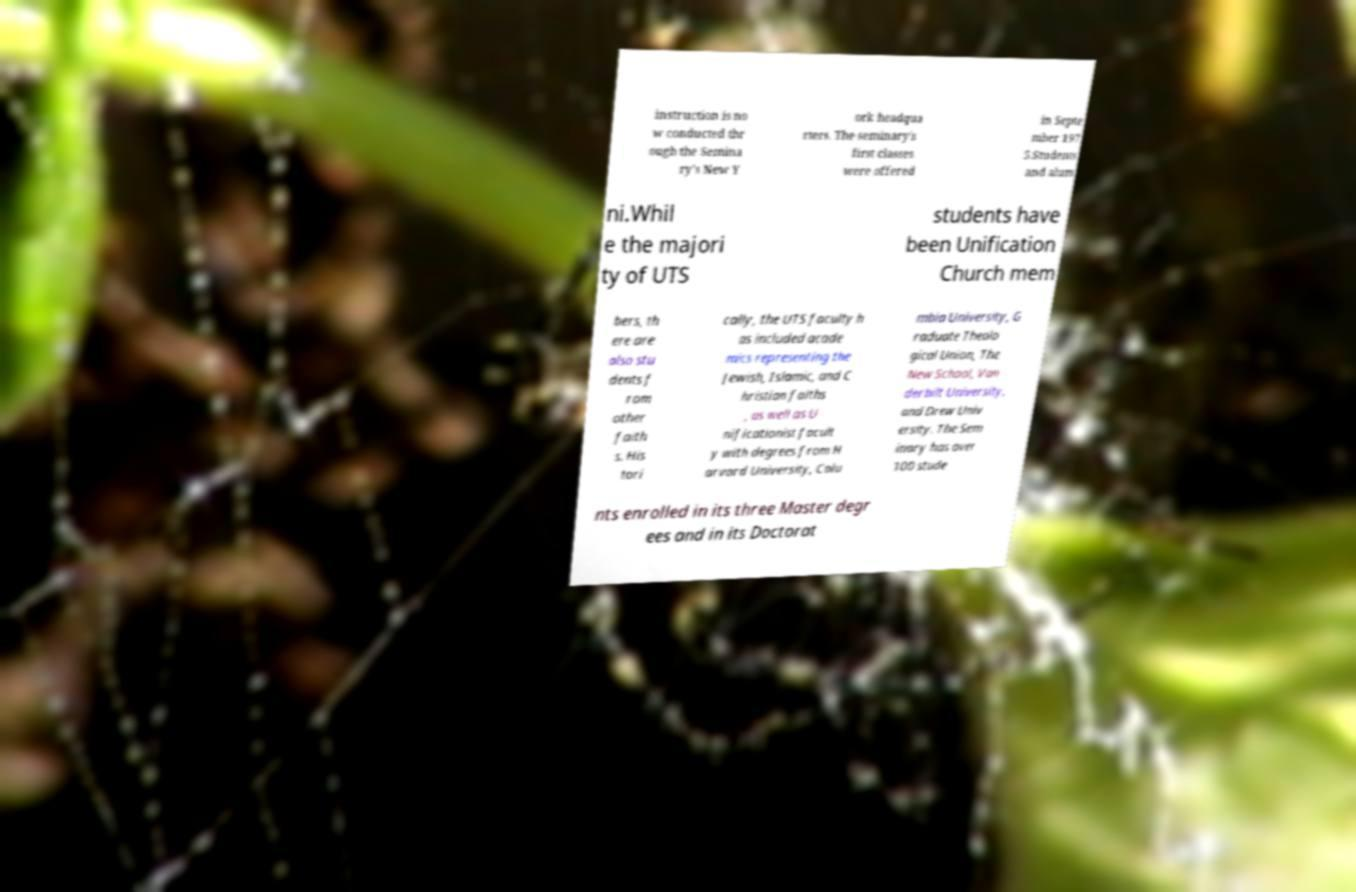Please identify and transcribe the text found in this image. instruction is no w conducted thr ough the Semina ry’s New Y ork headqua rters. The seminary's first classes were offered in Septe mber 197 5.Students and alum ni.Whil e the majori ty of UTS students have been Unification Church mem bers, th ere are also stu dents f rom other faith s. His tori cally, the UTS faculty h as included acade mics representing the Jewish, Islamic, and C hristian faiths , as well as U nificationist facult y with degrees from H arvard University, Colu mbia University, G raduate Theolo gical Union, The New School, Van derbilt University, and Drew Univ ersity. The Sem inary has over 100 stude nts enrolled in its three Master degr ees and in its Doctorat 